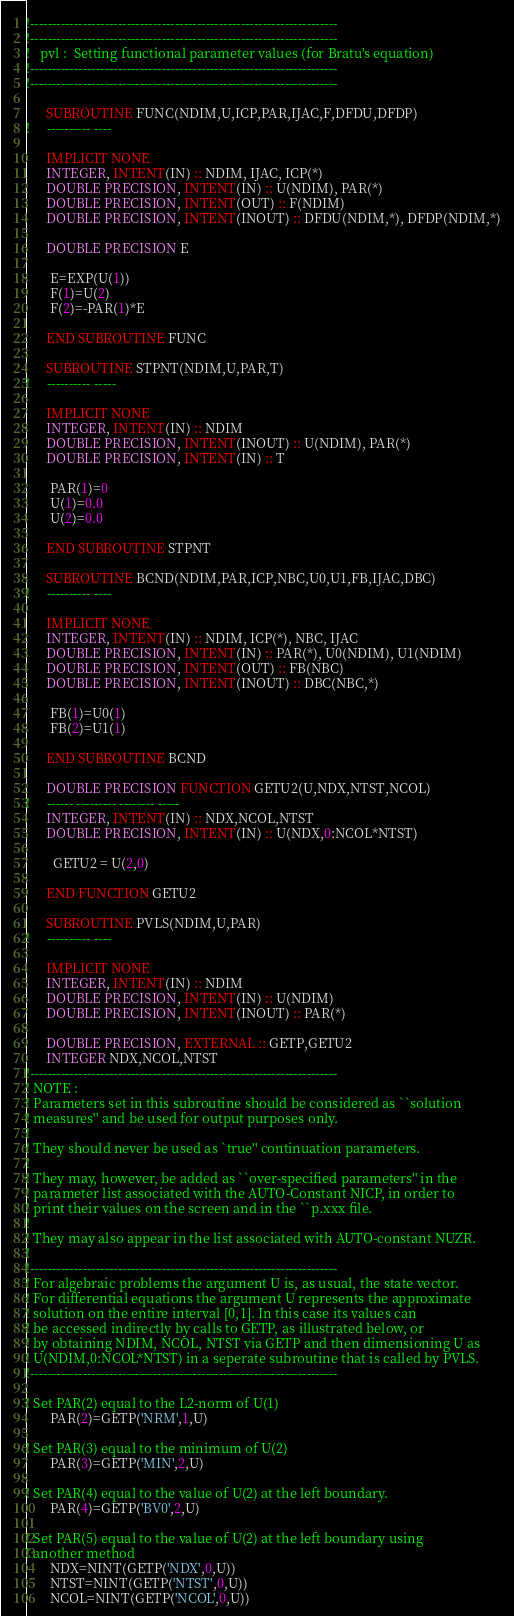Convert code to text. <code><loc_0><loc_0><loc_500><loc_500><_FORTRAN_>!---------------------------------------------------------------------- 
!---------------------------------------------------------------------- 
!   pvl :  Setting functional parameter values (for Bratu's equation)
!---------------------------------------------------------------------- 
!---------------------------------------------------------------------- 

      SUBROUTINE FUNC(NDIM,U,ICP,PAR,IJAC,F,DFDU,DFDP) 
!     ---------- ---- 

      IMPLICIT NONE
      INTEGER, INTENT(IN) :: NDIM, IJAC, ICP(*)
      DOUBLE PRECISION, INTENT(IN) :: U(NDIM), PAR(*)
      DOUBLE PRECISION, INTENT(OUT) :: F(NDIM)
      DOUBLE PRECISION, INTENT(INOUT) :: DFDU(NDIM,*), DFDP(NDIM,*)

      DOUBLE PRECISION E

       E=EXP(U(1)) 
       F(1)=U(2) 
       F(2)=-PAR(1)*E 

      END SUBROUTINE FUNC

      SUBROUTINE STPNT(NDIM,U,PAR,T) 
!     ---------- ----- 

      IMPLICIT NONE
      INTEGER, INTENT(IN) :: NDIM
      DOUBLE PRECISION, INTENT(INOUT) :: U(NDIM), PAR(*)
      DOUBLE PRECISION, INTENT(IN) :: T

       PAR(1)=0
       U(1)=0.0
       U(2)=0.0

      END SUBROUTINE STPNT

      SUBROUTINE BCND(NDIM,PAR,ICP,NBC,U0,U1,FB,IJAC,DBC) 
!     ---------- ---- 

      IMPLICIT NONE
      INTEGER, INTENT(IN) :: NDIM, ICP(*), NBC, IJAC
      DOUBLE PRECISION, INTENT(IN) :: PAR(*), U0(NDIM), U1(NDIM)
      DOUBLE PRECISION, INTENT(OUT) :: FB(NBC)
      DOUBLE PRECISION, INTENT(INOUT) :: DBC(NBC,*)

       FB(1)=U0(1)
       FB(2)=U1(1)

      END SUBROUTINE BCND

      DOUBLE PRECISION FUNCTION GETU2(U,NDX,NTST,NCOL)
!     ------ --------- -------- -----
      INTEGER, INTENT(IN) :: NDX,NCOL,NTST
      DOUBLE PRECISION, INTENT(IN) :: U(NDX,0:NCOL*NTST)

        GETU2 = U(2,0)

      END FUNCTION GETU2

      SUBROUTINE PVLS(NDIM,U,PAR)
!     ---------- ----

      IMPLICIT NONE
      INTEGER, INTENT(IN) :: NDIM
      DOUBLE PRECISION, INTENT(IN) :: U(NDIM)
      DOUBLE PRECISION, INTENT(INOUT) :: PAR(*)

      DOUBLE PRECISION, EXTERNAL :: GETP,GETU2
      INTEGER NDX,NCOL,NTST
!---------------------------------------------------------------------- 
! NOTE : 
! Parameters set in this subroutine should be considered as ``solution 
! measures'' and be used for output purposes only.
! 
! They should never be used as `true'' continuation parameters. 
!
! They may, however, be added as ``over-specified parameters'' in the 
! parameter list associated with the AUTO-Constant NICP, in order to 
! print their values on the screen and in the ``p.xxx file.
!
! They may also appear in the list associated with AUTO-constant NUZR.
!
!---------------------------------------------------------------------- 
! For algebraic problems the argument U is, as usual, the state vector.
! For differential equations the argument U represents the approximate 
! solution on the entire interval [0,1]. In this case its values can
! be accessed indirectly by calls to GETP, as illustrated below, or
! by obtaining NDIM, NCOL, NTST via GETP and then dimensioning U as
! U(NDIM,0:NCOL*NTST) in a seperate subroutine that is called by PVLS.
!---------------------------------------------------------------------- 

! Set PAR(2) equal to the L2-norm of U(1)
       PAR(2)=GETP('NRM',1,U)

! Set PAR(3) equal to the minimum of U(2)
       PAR(3)=GETP('MIN',2,U)

! Set PAR(4) equal to the value of U(2) at the left boundary.
       PAR(4)=GETP('BV0',2,U)

! Set PAR(5) equal to the value of U(2) at the left boundary using
! another method
       NDX=NINT(GETP('NDX',0,U))
       NTST=NINT(GETP('NTST',0,U))
       NCOL=NINT(GETP('NCOL',0,U))</code> 